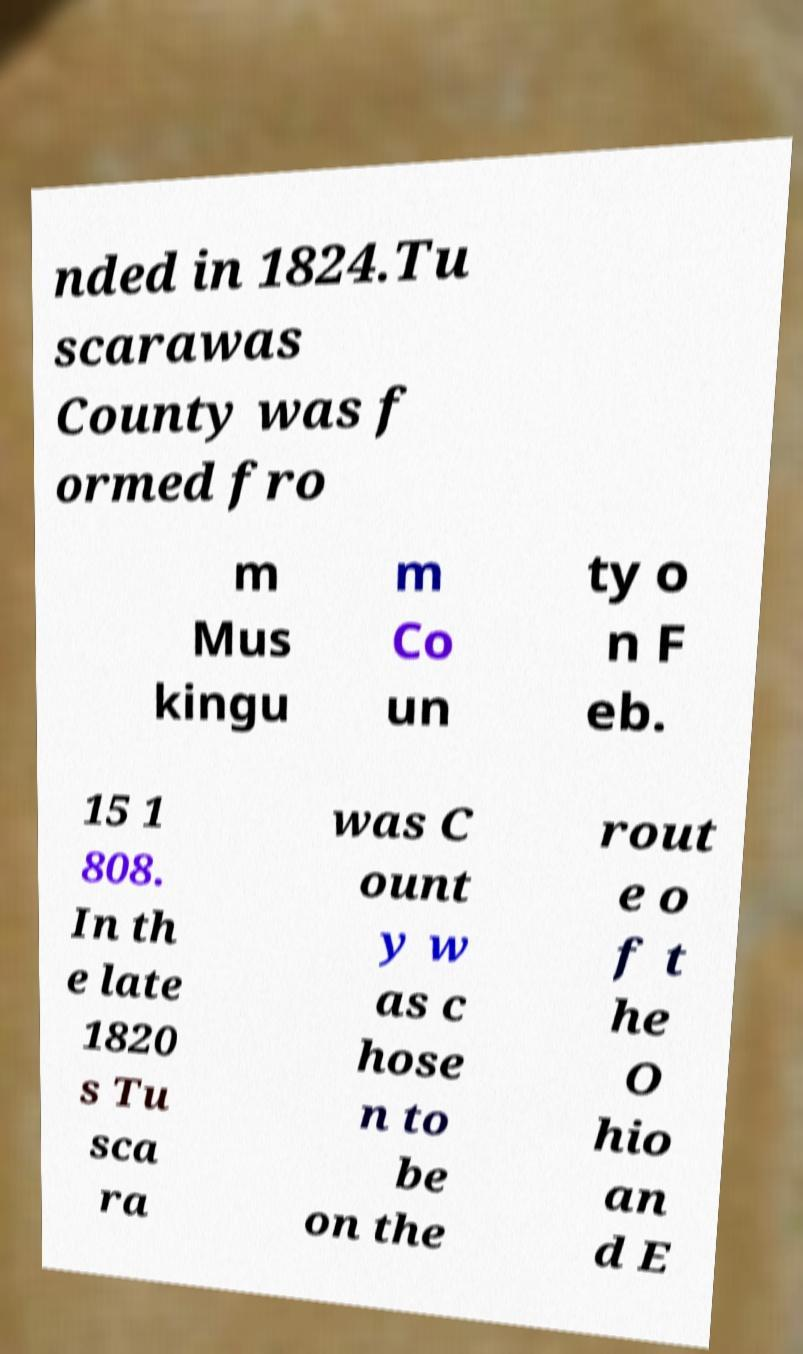Please identify and transcribe the text found in this image. nded in 1824.Tu scarawas County was f ormed fro m Mus kingu m Co un ty o n F eb. 15 1 808. In th e late 1820 s Tu sca ra was C ount y w as c hose n to be on the rout e o f t he O hio an d E 